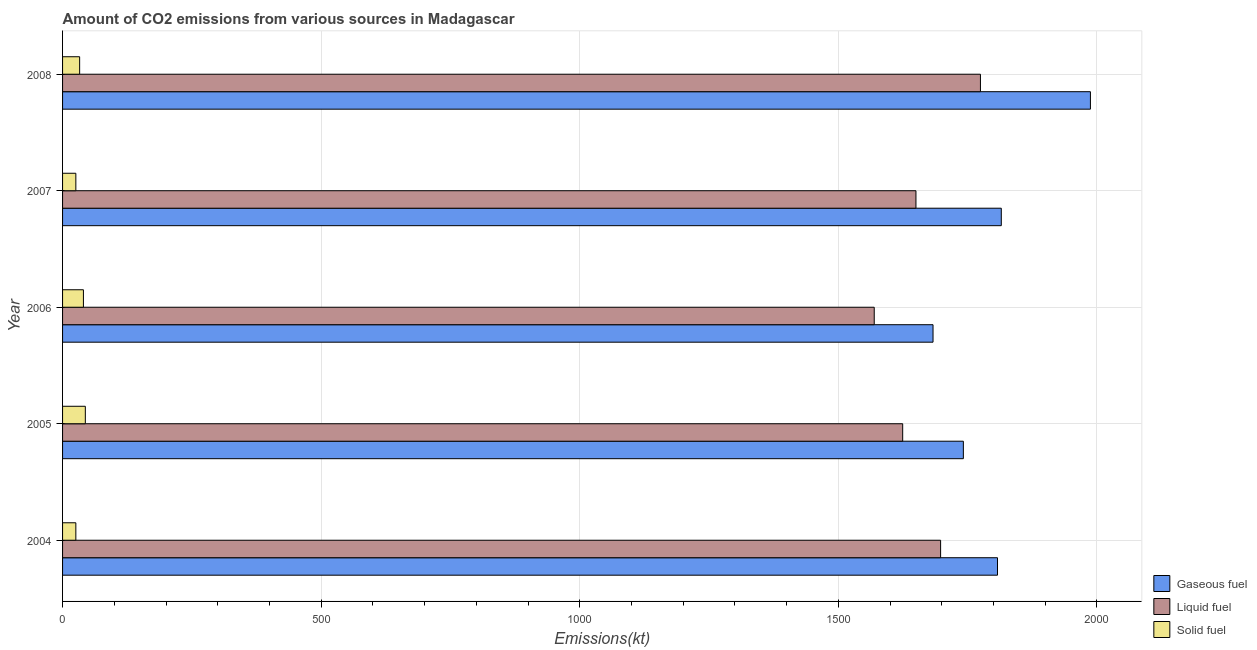Are the number of bars on each tick of the Y-axis equal?
Offer a very short reply. Yes. How many bars are there on the 2nd tick from the top?
Keep it short and to the point. 3. What is the label of the 2nd group of bars from the top?
Keep it short and to the point. 2007. What is the amount of co2 emissions from solid fuel in 2004?
Your answer should be compact. 25.67. Across all years, what is the maximum amount of co2 emissions from solid fuel?
Offer a terse response. 44. Across all years, what is the minimum amount of co2 emissions from gaseous fuel?
Make the answer very short. 1683.15. In which year was the amount of co2 emissions from liquid fuel maximum?
Offer a very short reply. 2008. In which year was the amount of co2 emissions from liquid fuel minimum?
Give a very brief answer. 2006. What is the total amount of co2 emissions from solid fuel in the graph?
Provide a short and direct response. 168.68. What is the difference between the amount of co2 emissions from liquid fuel in 2006 and that in 2007?
Provide a succinct answer. -80.67. What is the difference between the amount of co2 emissions from solid fuel in 2007 and the amount of co2 emissions from liquid fuel in 2005?
Provide a short and direct response. -1598.81. What is the average amount of co2 emissions from liquid fuel per year?
Provide a short and direct response. 1663.35. In the year 2005, what is the difference between the amount of co2 emissions from liquid fuel and amount of co2 emissions from solid fuel?
Make the answer very short. 1580.48. What is the ratio of the amount of co2 emissions from gaseous fuel in 2006 to that in 2008?
Offer a terse response. 0.85. Is the amount of co2 emissions from gaseous fuel in 2004 less than that in 2005?
Make the answer very short. No. Is the difference between the amount of co2 emissions from liquid fuel in 2005 and 2007 greater than the difference between the amount of co2 emissions from solid fuel in 2005 and 2007?
Ensure brevity in your answer.  No. What is the difference between the highest and the second highest amount of co2 emissions from gaseous fuel?
Offer a terse response. 172.35. What is the difference between the highest and the lowest amount of co2 emissions from solid fuel?
Offer a very short reply. 18.33. Is the sum of the amount of co2 emissions from liquid fuel in 2005 and 2006 greater than the maximum amount of co2 emissions from solid fuel across all years?
Your response must be concise. Yes. What does the 1st bar from the top in 2006 represents?
Offer a terse response. Solid fuel. What does the 1st bar from the bottom in 2005 represents?
Make the answer very short. Gaseous fuel. Is it the case that in every year, the sum of the amount of co2 emissions from gaseous fuel and amount of co2 emissions from liquid fuel is greater than the amount of co2 emissions from solid fuel?
Provide a succinct answer. Yes. Are the values on the major ticks of X-axis written in scientific E-notation?
Keep it short and to the point. No. Does the graph contain any zero values?
Make the answer very short. No. How many legend labels are there?
Make the answer very short. 3. How are the legend labels stacked?
Your response must be concise. Vertical. What is the title of the graph?
Provide a succinct answer. Amount of CO2 emissions from various sources in Madagascar. What is the label or title of the X-axis?
Keep it short and to the point. Emissions(kt). What is the Emissions(kt) in Gaseous fuel in 2004?
Provide a succinct answer. 1807.83. What is the Emissions(kt) in Liquid fuel in 2004?
Keep it short and to the point. 1697.82. What is the Emissions(kt) in Solid fuel in 2004?
Offer a very short reply. 25.67. What is the Emissions(kt) in Gaseous fuel in 2005?
Offer a terse response. 1741.83. What is the Emissions(kt) in Liquid fuel in 2005?
Offer a very short reply. 1624.48. What is the Emissions(kt) of Solid fuel in 2005?
Offer a terse response. 44. What is the Emissions(kt) of Gaseous fuel in 2006?
Make the answer very short. 1683.15. What is the Emissions(kt) of Liquid fuel in 2006?
Your answer should be compact. 1569.48. What is the Emissions(kt) in Solid fuel in 2006?
Provide a short and direct response. 40.34. What is the Emissions(kt) in Gaseous fuel in 2007?
Your answer should be compact. 1815.16. What is the Emissions(kt) of Liquid fuel in 2007?
Provide a short and direct response. 1650.15. What is the Emissions(kt) of Solid fuel in 2007?
Your answer should be very brief. 25.67. What is the Emissions(kt) in Gaseous fuel in 2008?
Your answer should be compact. 1987.51. What is the Emissions(kt) of Liquid fuel in 2008?
Give a very brief answer. 1774.83. What is the Emissions(kt) of Solid fuel in 2008?
Your answer should be very brief. 33. Across all years, what is the maximum Emissions(kt) of Gaseous fuel?
Your answer should be compact. 1987.51. Across all years, what is the maximum Emissions(kt) in Liquid fuel?
Your answer should be very brief. 1774.83. Across all years, what is the maximum Emissions(kt) in Solid fuel?
Your answer should be compact. 44. Across all years, what is the minimum Emissions(kt) in Gaseous fuel?
Give a very brief answer. 1683.15. Across all years, what is the minimum Emissions(kt) of Liquid fuel?
Provide a succinct answer. 1569.48. Across all years, what is the minimum Emissions(kt) of Solid fuel?
Provide a short and direct response. 25.67. What is the total Emissions(kt) in Gaseous fuel in the graph?
Your response must be concise. 9035.49. What is the total Emissions(kt) in Liquid fuel in the graph?
Ensure brevity in your answer.  8316.76. What is the total Emissions(kt) of Solid fuel in the graph?
Your answer should be compact. 168.68. What is the difference between the Emissions(kt) in Gaseous fuel in 2004 and that in 2005?
Ensure brevity in your answer.  66.01. What is the difference between the Emissions(kt) in Liquid fuel in 2004 and that in 2005?
Offer a very short reply. 73.34. What is the difference between the Emissions(kt) in Solid fuel in 2004 and that in 2005?
Your response must be concise. -18.34. What is the difference between the Emissions(kt) of Gaseous fuel in 2004 and that in 2006?
Provide a short and direct response. 124.68. What is the difference between the Emissions(kt) in Liquid fuel in 2004 and that in 2006?
Your response must be concise. 128.34. What is the difference between the Emissions(kt) in Solid fuel in 2004 and that in 2006?
Ensure brevity in your answer.  -14.67. What is the difference between the Emissions(kt) of Gaseous fuel in 2004 and that in 2007?
Your response must be concise. -7.33. What is the difference between the Emissions(kt) in Liquid fuel in 2004 and that in 2007?
Offer a very short reply. 47.67. What is the difference between the Emissions(kt) of Solid fuel in 2004 and that in 2007?
Offer a very short reply. 0. What is the difference between the Emissions(kt) in Gaseous fuel in 2004 and that in 2008?
Provide a succinct answer. -179.68. What is the difference between the Emissions(kt) of Liquid fuel in 2004 and that in 2008?
Ensure brevity in your answer.  -77.01. What is the difference between the Emissions(kt) of Solid fuel in 2004 and that in 2008?
Your answer should be very brief. -7.33. What is the difference between the Emissions(kt) in Gaseous fuel in 2005 and that in 2006?
Make the answer very short. 58.67. What is the difference between the Emissions(kt) of Liquid fuel in 2005 and that in 2006?
Your answer should be compact. 55.01. What is the difference between the Emissions(kt) of Solid fuel in 2005 and that in 2006?
Make the answer very short. 3.67. What is the difference between the Emissions(kt) of Gaseous fuel in 2005 and that in 2007?
Give a very brief answer. -73.34. What is the difference between the Emissions(kt) in Liquid fuel in 2005 and that in 2007?
Your answer should be compact. -25.67. What is the difference between the Emissions(kt) in Solid fuel in 2005 and that in 2007?
Your answer should be compact. 18.34. What is the difference between the Emissions(kt) of Gaseous fuel in 2005 and that in 2008?
Provide a short and direct response. -245.69. What is the difference between the Emissions(kt) in Liquid fuel in 2005 and that in 2008?
Your response must be concise. -150.35. What is the difference between the Emissions(kt) in Solid fuel in 2005 and that in 2008?
Provide a succinct answer. 11. What is the difference between the Emissions(kt) of Gaseous fuel in 2006 and that in 2007?
Offer a terse response. -132.01. What is the difference between the Emissions(kt) in Liquid fuel in 2006 and that in 2007?
Make the answer very short. -80.67. What is the difference between the Emissions(kt) in Solid fuel in 2006 and that in 2007?
Provide a succinct answer. 14.67. What is the difference between the Emissions(kt) of Gaseous fuel in 2006 and that in 2008?
Make the answer very short. -304.36. What is the difference between the Emissions(kt) of Liquid fuel in 2006 and that in 2008?
Keep it short and to the point. -205.35. What is the difference between the Emissions(kt) of Solid fuel in 2006 and that in 2008?
Make the answer very short. 7.33. What is the difference between the Emissions(kt) in Gaseous fuel in 2007 and that in 2008?
Your answer should be very brief. -172.35. What is the difference between the Emissions(kt) in Liquid fuel in 2007 and that in 2008?
Offer a terse response. -124.68. What is the difference between the Emissions(kt) in Solid fuel in 2007 and that in 2008?
Your answer should be compact. -7.33. What is the difference between the Emissions(kt) in Gaseous fuel in 2004 and the Emissions(kt) in Liquid fuel in 2005?
Ensure brevity in your answer.  183.35. What is the difference between the Emissions(kt) of Gaseous fuel in 2004 and the Emissions(kt) of Solid fuel in 2005?
Offer a terse response. 1763.83. What is the difference between the Emissions(kt) in Liquid fuel in 2004 and the Emissions(kt) in Solid fuel in 2005?
Make the answer very short. 1653.82. What is the difference between the Emissions(kt) of Gaseous fuel in 2004 and the Emissions(kt) of Liquid fuel in 2006?
Ensure brevity in your answer.  238.35. What is the difference between the Emissions(kt) of Gaseous fuel in 2004 and the Emissions(kt) of Solid fuel in 2006?
Provide a short and direct response. 1767.49. What is the difference between the Emissions(kt) in Liquid fuel in 2004 and the Emissions(kt) in Solid fuel in 2006?
Offer a very short reply. 1657.48. What is the difference between the Emissions(kt) of Gaseous fuel in 2004 and the Emissions(kt) of Liquid fuel in 2007?
Your answer should be compact. 157.68. What is the difference between the Emissions(kt) of Gaseous fuel in 2004 and the Emissions(kt) of Solid fuel in 2007?
Give a very brief answer. 1782.16. What is the difference between the Emissions(kt) in Liquid fuel in 2004 and the Emissions(kt) in Solid fuel in 2007?
Give a very brief answer. 1672.15. What is the difference between the Emissions(kt) of Gaseous fuel in 2004 and the Emissions(kt) of Liquid fuel in 2008?
Make the answer very short. 33. What is the difference between the Emissions(kt) in Gaseous fuel in 2004 and the Emissions(kt) in Solid fuel in 2008?
Provide a short and direct response. 1774.83. What is the difference between the Emissions(kt) of Liquid fuel in 2004 and the Emissions(kt) of Solid fuel in 2008?
Offer a terse response. 1664.82. What is the difference between the Emissions(kt) of Gaseous fuel in 2005 and the Emissions(kt) of Liquid fuel in 2006?
Offer a terse response. 172.35. What is the difference between the Emissions(kt) of Gaseous fuel in 2005 and the Emissions(kt) of Solid fuel in 2006?
Your answer should be compact. 1701.49. What is the difference between the Emissions(kt) of Liquid fuel in 2005 and the Emissions(kt) of Solid fuel in 2006?
Offer a terse response. 1584.14. What is the difference between the Emissions(kt) of Gaseous fuel in 2005 and the Emissions(kt) of Liquid fuel in 2007?
Provide a succinct answer. 91.67. What is the difference between the Emissions(kt) of Gaseous fuel in 2005 and the Emissions(kt) of Solid fuel in 2007?
Ensure brevity in your answer.  1716.16. What is the difference between the Emissions(kt) of Liquid fuel in 2005 and the Emissions(kt) of Solid fuel in 2007?
Give a very brief answer. 1598.81. What is the difference between the Emissions(kt) in Gaseous fuel in 2005 and the Emissions(kt) in Liquid fuel in 2008?
Ensure brevity in your answer.  -33. What is the difference between the Emissions(kt) of Gaseous fuel in 2005 and the Emissions(kt) of Solid fuel in 2008?
Provide a succinct answer. 1708.82. What is the difference between the Emissions(kt) of Liquid fuel in 2005 and the Emissions(kt) of Solid fuel in 2008?
Give a very brief answer. 1591.48. What is the difference between the Emissions(kt) of Gaseous fuel in 2006 and the Emissions(kt) of Liquid fuel in 2007?
Provide a succinct answer. 33. What is the difference between the Emissions(kt) of Gaseous fuel in 2006 and the Emissions(kt) of Solid fuel in 2007?
Keep it short and to the point. 1657.48. What is the difference between the Emissions(kt) in Liquid fuel in 2006 and the Emissions(kt) in Solid fuel in 2007?
Keep it short and to the point. 1543.81. What is the difference between the Emissions(kt) of Gaseous fuel in 2006 and the Emissions(kt) of Liquid fuel in 2008?
Your answer should be compact. -91.67. What is the difference between the Emissions(kt) of Gaseous fuel in 2006 and the Emissions(kt) of Solid fuel in 2008?
Offer a terse response. 1650.15. What is the difference between the Emissions(kt) of Liquid fuel in 2006 and the Emissions(kt) of Solid fuel in 2008?
Keep it short and to the point. 1536.47. What is the difference between the Emissions(kt) of Gaseous fuel in 2007 and the Emissions(kt) of Liquid fuel in 2008?
Provide a short and direct response. 40.34. What is the difference between the Emissions(kt) of Gaseous fuel in 2007 and the Emissions(kt) of Solid fuel in 2008?
Provide a short and direct response. 1782.16. What is the difference between the Emissions(kt) of Liquid fuel in 2007 and the Emissions(kt) of Solid fuel in 2008?
Keep it short and to the point. 1617.15. What is the average Emissions(kt) in Gaseous fuel per year?
Offer a very short reply. 1807.1. What is the average Emissions(kt) of Liquid fuel per year?
Your response must be concise. 1663.35. What is the average Emissions(kt) in Solid fuel per year?
Provide a succinct answer. 33.74. In the year 2004, what is the difference between the Emissions(kt) of Gaseous fuel and Emissions(kt) of Liquid fuel?
Provide a succinct answer. 110.01. In the year 2004, what is the difference between the Emissions(kt) of Gaseous fuel and Emissions(kt) of Solid fuel?
Ensure brevity in your answer.  1782.16. In the year 2004, what is the difference between the Emissions(kt) in Liquid fuel and Emissions(kt) in Solid fuel?
Keep it short and to the point. 1672.15. In the year 2005, what is the difference between the Emissions(kt) of Gaseous fuel and Emissions(kt) of Liquid fuel?
Offer a very short reply. 117.34. In the year 2005, what is the difference between the Emissions(kt) in Gaseous fuel and Emissions(kt) in Solid fuel?
Keep it short and to the point. 1697.82. In the year 2005, what is the difference between the Emissions(kt) of Liquid fuel and Emissions(kt) of Solid fuel?
Ensure brevity in your answer.  1580.48. In the year 2006, what is the difference between the Emissions(kt) in Gaseous fuel and Emissions(kt) in Liquid fuel?
Your answer should be compact. 113.68. In the year 2006, what is the difference between the Emissions(kt) of Gaseous fuel and Emissions(kt) of Solid fuel?
Offer a terse response. 1642.82. In the year 2006, what is the difference between the Emissions(kt) of Liquid fuel and Emissions(kt) of Solid fuel?
Give a very brief answer. 1529.14. In the year 2007, what is the difference between the Emissions(kt) of Gaseous fuel and Emissions(kt) of Liquid fuel?
Keep it short and to the point. 165.01. In the year 2007, what is the difference between the Emissions(kt) of Gaseous fuel and Emissions(kt) of Solid fuel?
Your answer should be compact. 1789.5. In the year 2007, what is the difference between the Emissions(kt) in Liquid fuel and Emissions(kt) in Solid fuel?
Keep it short and to the point. 1624.48. In the year 2008, what is the difference between the Emissions(kt) in Gaseous fuel and Emissions(kt) in Liquid fuel?
Provide a succinct answer. 212.69. In the year 2008, what is the difference between the Emissions(kt) in Gaseous fuel and Emissions(kt) in Solid fuel?
Ensure brevity in your answer.  1954.51. In the year 2008, what is the difference between the Emissions(kt) of Liquid fuel and Emissions(kt) of Solid fuel?
Your answer should be very brief. 1741.83. What is the ratio of the Emissions(kt) in Gaseous fuel in 2004 to that in 2005?
Provide a succinct answer. 1.04. What is the ratio of the Emissions(kt) of Liquid fuel in 2004 to that in 2005?
Your answer should be compact. 1.05. What is the ratio of the Emissions(kt) in Solid fuel in 2004 to that in 2005?
Your answer should be very brief. 0.58. What is the ratio of the Emissions(kt) of Gaseous fuel in 2004 to that in 2006?
Give a very brief answer. 1.07. What is the ratio of the Emissions(kt) of Liquid fuel in 2004 to that in 2006?
Provide a succinct answer. 1.08. What is the ratio of the Emissions(kt) in Solid fuel in 2004 to that in 2006?
Keep it short and to the point. 0.64. What is the ratio of the Emissions(kt) of Gaseous fuel in 2004 to that in 2007?
Offer a very short reply. 1. What is the ratio of the Emissions(kt) of Liquid fuel in 2004 to that in 2007?
Your answer should be very brief. 1.03. What is the ratio of the Emissions(kt) of Solid fuel in 2004 to that in 2007?
Offer a very short reply. 1. What is the ratio of the Emissions(kt) of Gaseous fuel in 2004 to that in 2008?
Provide a succinct answer. 0.91. What is the ratio of the Emissions(kt) of Liquid fuel in 2004 to that in 2008?
Your answer should be very brief. 0.96. What is the ratio of the Emissions(kt) in Gaseous fuel in 2005 to that in 2006?
Offer a terse response. 1.03. What is the ratio of the Emissions(kt) of Liquid fuel in 2005 to that in 2006?
Offer a terse response. 1.03. What is the ratio of the Emissions(kt) of Solid fuel in 2005 to that in 2006?
Provide a short and direct response. 1.09. What is the ratio of the Emissions(kt) in Gaseous fuel in 2005 to that in 2007?
Your answer should be compact. 0.96. What is the ratio of the Emissions(kt) of Liquid fuel in 2005 to that in 2007?
Give a very brief answer. 0.98. What is the ratio of the Emissions(kt) in Solid fuel in 2005 to that in 2007?
Ensure brevity in your answer.  1.71. What is the ratio of the Emissions(kt) in Gaseous fuel in 2005 to that in 2008?
Your answer should be very brief. 0.88. What is the ratio of the Emissions(kt) in Liquid fuel in 2005 to that in 2008?
Your answer should be compact. 0.92. What is the ratio of the Emissions(kt) of Solid fuel in 2005 to that in 2008?
Make the answer very short. 1.33. What is the ratio of the Emissions(kt) in Gaseous fuel in 2006 to that in 2007?
Keep it short and to the point. 0.93. What is the ratio of the Emissions(kt) of Liquid fuel in 2006 to that in 2007?
Offer a terse response. 0.95. What is the ratio of the Emissions(kt) in Solid fuel in 2006 to that in 2007?
Provide a short and direct response. 1.57. What is the ratio of the Emissions(kt) in Gaseous fuel in 2006 to that in 2008?
Your response must be concise. 0.85. What is the ratio of the Emissions(kt) in Liquid fuel in 2006 to that in 2008?
Offer a very short reply. 0.88. What is the ratio of the Emissions(kt) of Solid fuel in 2006 to that in 2008?
Make the answer very short. 1.22. What is the ratio of the Emissions(kt) in Gaseous fuel in 2007 to that in 2008?
Ensure brevity in your answer.  0.91. What is the ratio of the Emissions(kt) in Liquid fuel in 2007 to that in 2008?
Ensure brevity in your answer.  0.93. What is the ratio of the Emissions(kt) of Solid fuel in 2007 to that in 2008?
Your answer should be very brief. 0.78. What is the difference between the highest and the second highest Emissions(kt) of Gaseous fuel?
Make the answer very short. 172.35. What is the difference between the highest and the second highest Emissions(kt) in Liquid fuel?
Your answer should be very brief. 77.01. What is the difference between the highest and the second highest Emissions(kt) of Solid fuel?
Make the answer very short. 3.67. What is the difference between the highest and the lowest Emissions(kt) in Gaseous fuel?
Offer a terse response. 304.36. What is the difference between the highest and the lowest Emissions(kt) of Liquid fuel?
Keep it short and to the point. 205.35. What is the difference between the highest and the lowest Emissions(kt) of Solid fuel?
Your answer should be very brief. 18.34. 